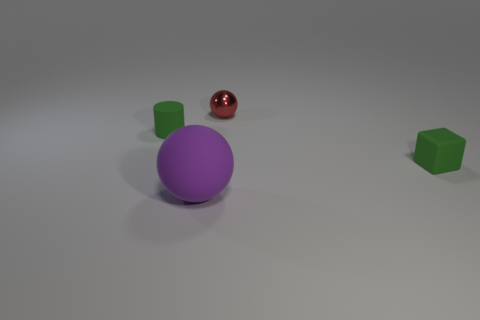Are there any other things that are the same size as the purple sphere?
Make the answer very short. No. How many rubber cubes are the same color as the tiny rubber cylinder?
Make the answer very short. 1. What size is the purple rubber sphere?
Offer a very short reply. Large. The green matte object that is right of the matte sphere has what shape?
Your answer should be very brief. Cube. Are there an equal number of small green matte objects behind the green matte block and green objects?
Ensure brevity in your answer.  No. What is the shape of the large purple matte object?
Provide a short and direct response. Sphere. Is there anything else that is the same color as the block?
Offer a terse response. Yes. Is the size of the rubber object that is on the right side of the purple sphere the same as the purple matte sphere that is to the right of the tiny cylinder?
Keep it short and to the point. No. What is the shape of the small thing on the left side of the thing that is behind the small cylinder?
Your response must be concise. Cylinder. There is a rubber block; does it have the same size as the green thing that is to the left of the large purple matte sphere?
Give a very brief answer. Yes. 